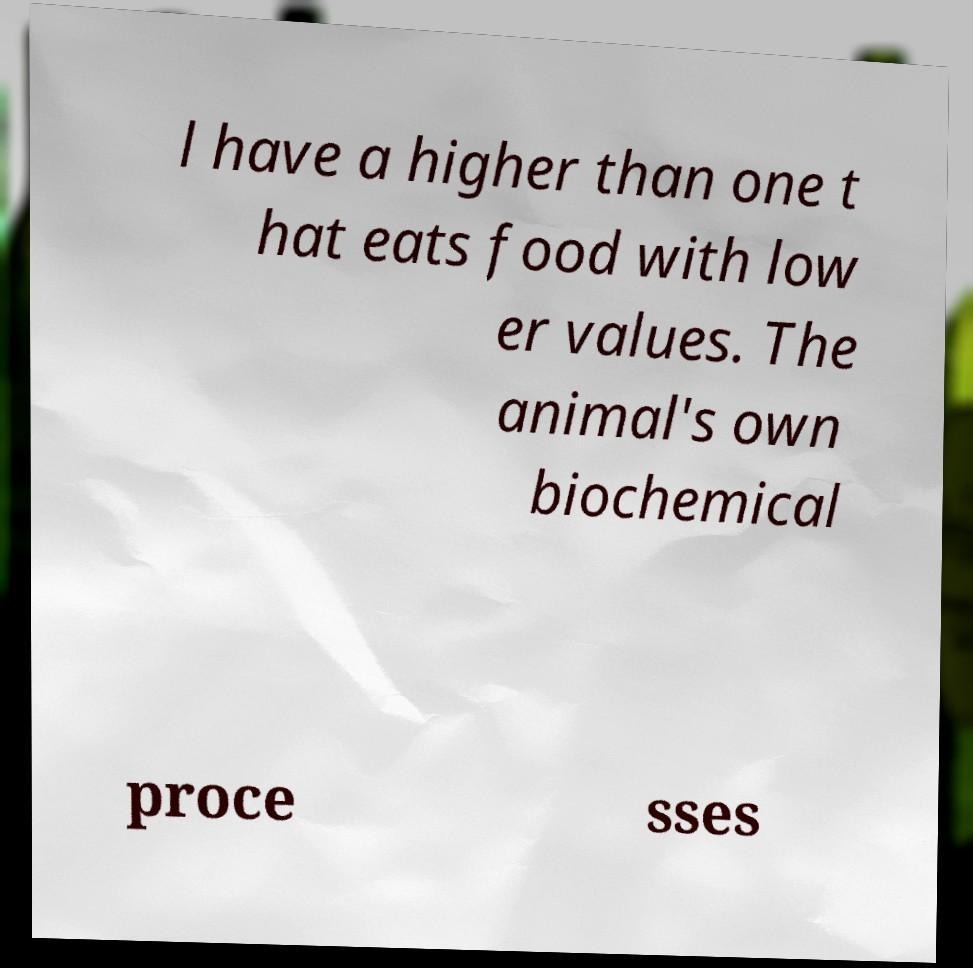There's text embedded in this image that I need extracted. Can you transcribe it verbatim? l have a higher than one t hat eats food with low er values. The animal's own biochemical proce sses 